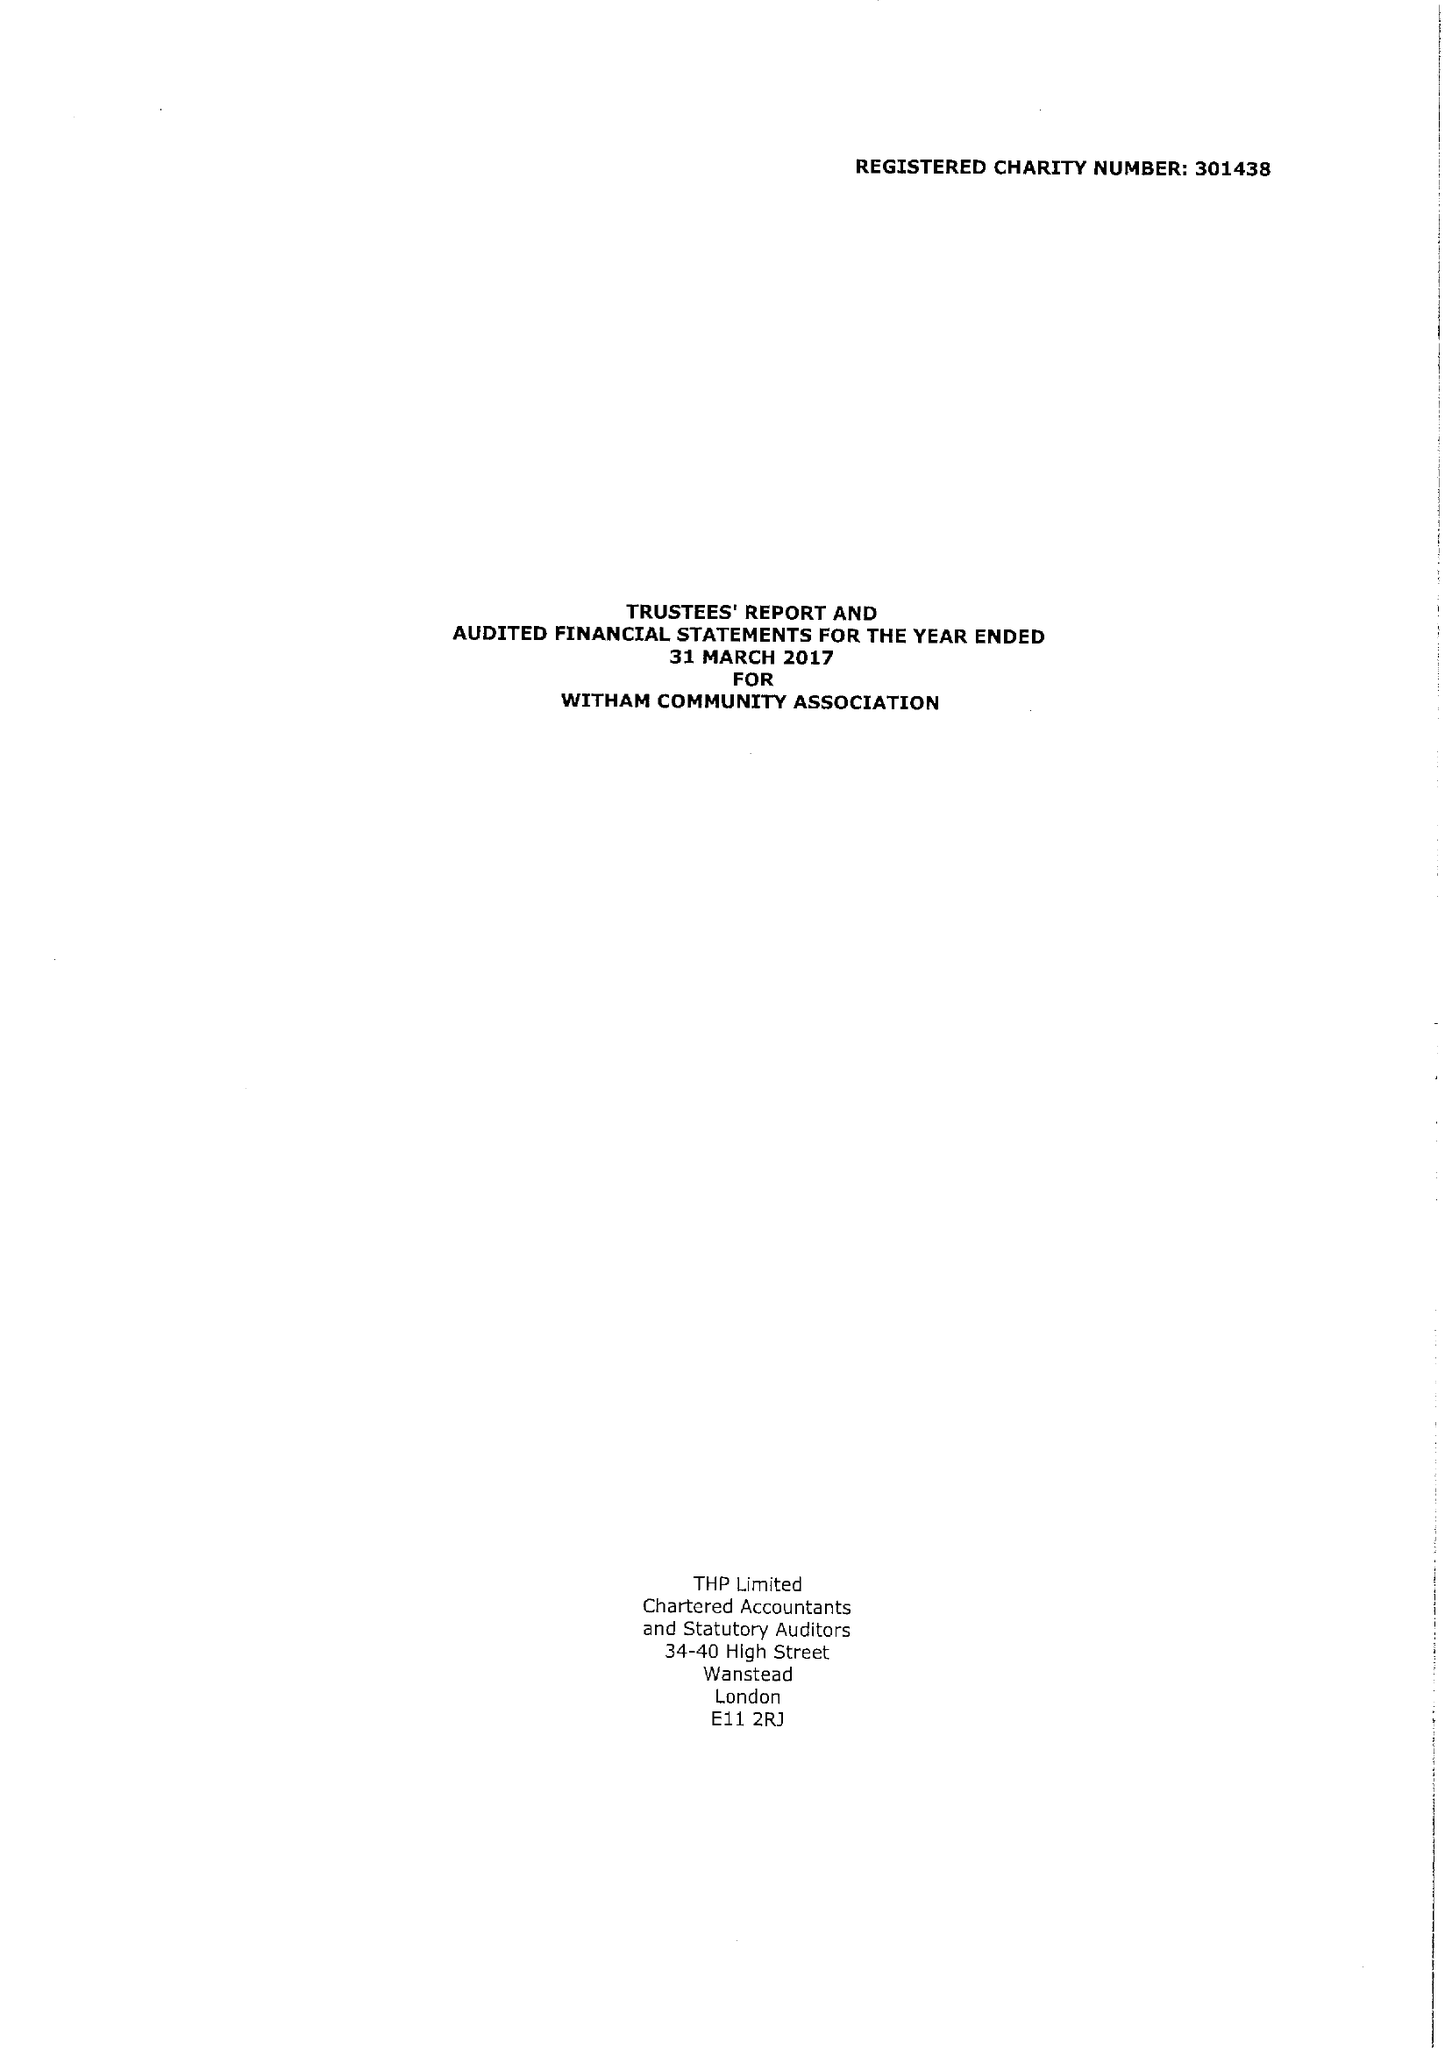What is the value for the address__post_town?
Answer the question using a single word or phrase. WITHAM 